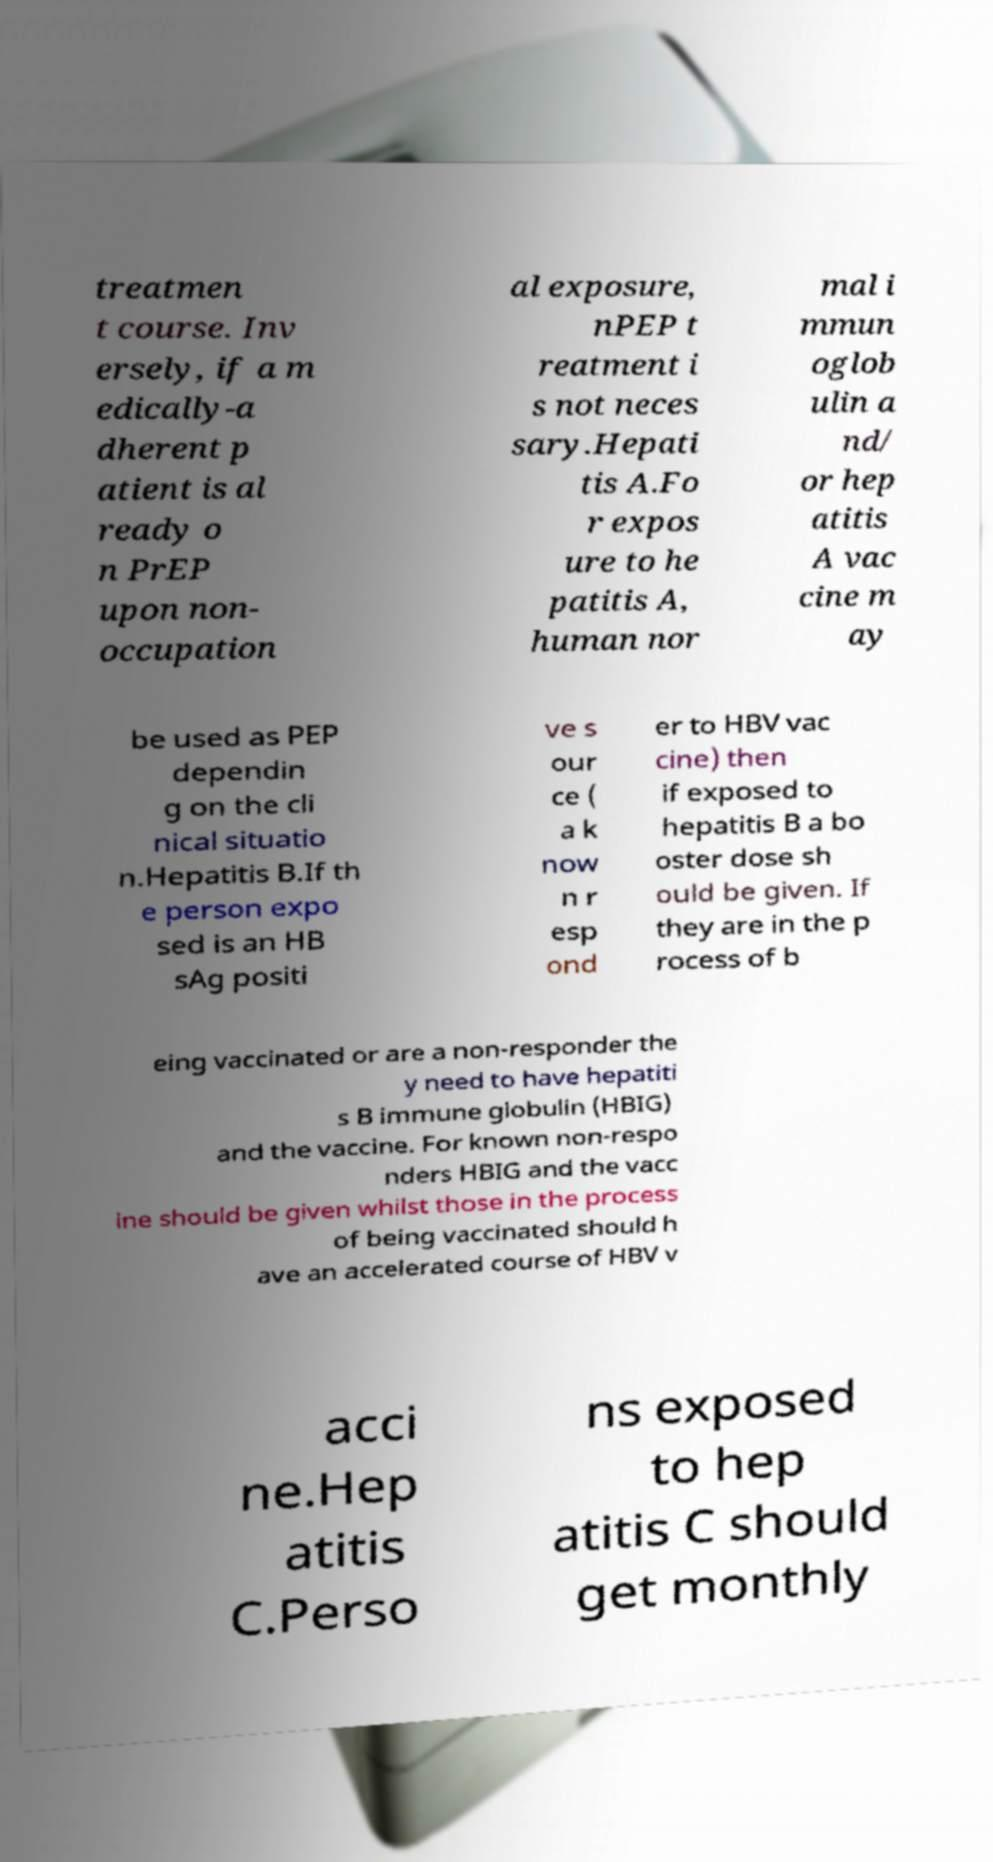There's text embedded in this image that I need extracted. Can you transcribe it verbatim? treatmen t course. Inv ersely, if a m edically-a dherent p atient is al ready o n PrEP upon non- occupation al exposure, nPEP t reatment i s not neces sary.Hepati tis A.Fo r expos ure to he patitis A, human nor mal i mmun oglob ulin a nd/ or hep atitis A vac cine m ay be used as PEP dependin g on the cli nical situatio n.Hepatitis B.If th e person expo sed is an HB sAg positi ve s our ce ( a k now n r esp ond er to HBV vac cine) then if exposed to hepatitis B a bo oster dose sh ould be given. If they are in the p rocess of b eing vaccinated or are a non-responder the y need to have hepatiti s B immune globulin (HBIG) and the vaccine. For known non-respo nders HBIG and the vacc ine should be given whilst those in the process of being vaccinated should h ave an accelerated course of HBV v acci ne.Hep atitis C.Perso ns exposed to hep atitis C should get monthly 